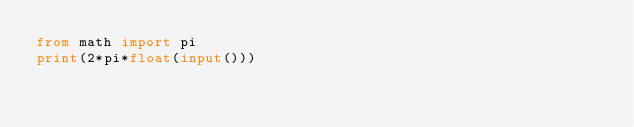Convert code to text. <code><loc_0><loc_0><loc_500><loc_500><_Python_>from math import pi
print(2*pi*float(input()))
</code> 